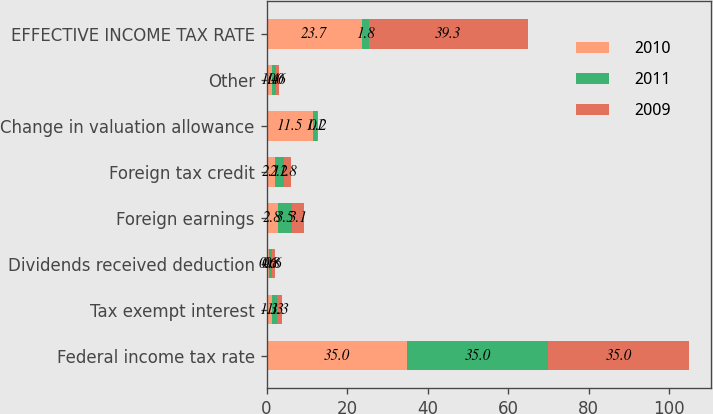<chart> <loc_0><loc_0><loc_500><loc_500><stacked_bar_chart><ecel><fcel>Federal income tax rate<fcel>Tax exempt interest<fcel>Dividends received deduction<fcel>Foreign earnings<fcel>Foreign tax credit<fcel>Change in valuation allowance<fcel>Other<fcel>EFFECTIVE INCOME TAX RATE<nl><fcel>2010<fcel>35<fcel>1.3<fcel>0.6<fcel>2.8<fcel>2.1<fcel>11.5<fcel>1.4<fcel>23.7<nl><fcel>2011<fcel>35<fcel>1.3<fcel>0.8<fcel>3.5<fcel>2.2<fcel>1.1<fcel>1<fcel>1.8<nl><fcel>2009<fcel>35<fcel>1.3<fcel>0.6<fcel>3.1<fcel>1.8<fcel>0.2<fcel>0.6<fcel>39.3<nl></chart> 